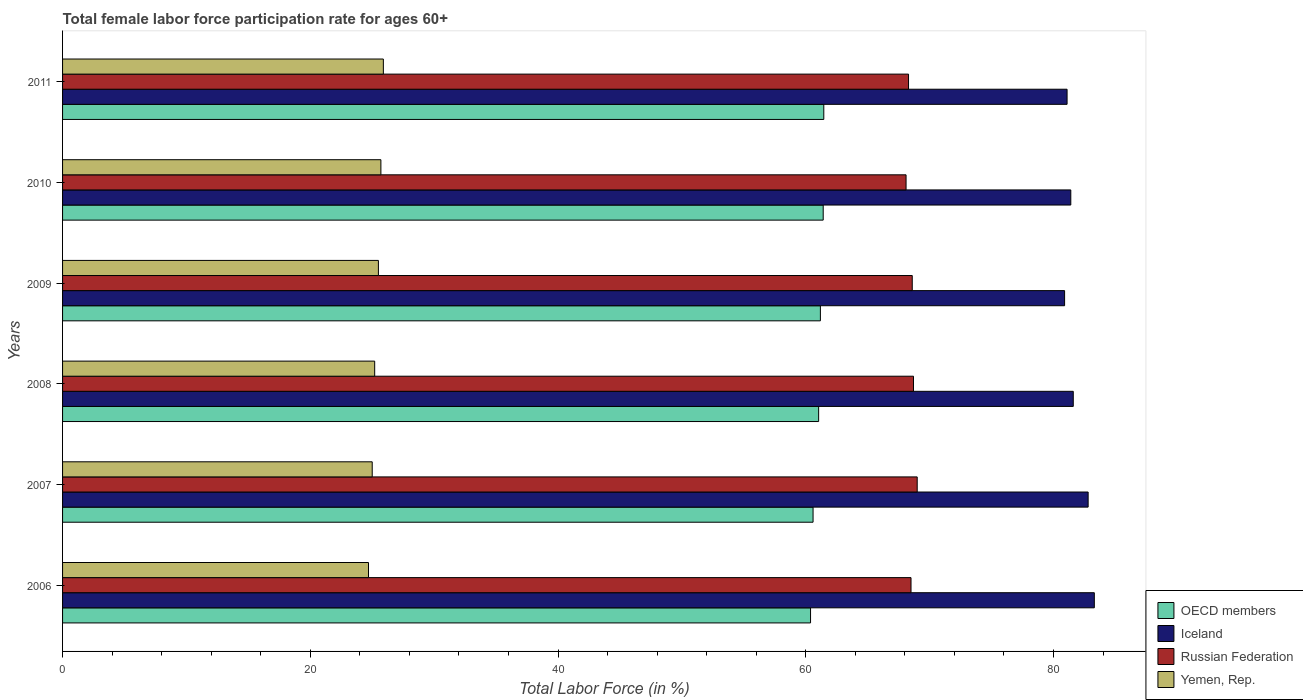Are the number of bars per tick equal to the number of legend labels?
Your answer should be compact. Yes. Are the number of bars on each tick of the Y-axis equal?
Offer a terse response. Yes. How many bars are there on the 6th tick from the bottom?
Make the answer very short. 4. What is the label of the 6th group of bars from the top?
Provide a short and direct response. 2006. What is the female labor force participation rate in Iceland in 2011?
Offer a terse response. 81.1. Across all years, what is the minimum female labor force participation rate in Iceland?
Offer a very short reply. 80.9. In which year was the female labor force participation rate in OECD members minimum?
Make the answer very short. 2006. What is the total female labor force participation rate in OECD members in the graph?
Provide a succinct answer. 366.08. What is the difference between the female labor force participation rate in Yemen, Rep. in 2007 and that in 2010?
Your answer should be compact. -0.7. What is the difference between the female labor force participation rate in Iceland in 2010 and the female labor force participation rate in OECD members in 2009?
Keep it short and to the point. 20.22. What is the average female labor force participation rate in Russian Federation per year?
Give a very brief answer. 68.53. In the year 2007, what is the difference between the female labor force participation rate in OECD members and female labor force participation rate in Russian Federation?
Your answer should be compact. -8.41. What is the ratio of the female labor force participation rate in Iceland in 2007 to that in 2011?
Make the answer very short. 1.02. Is the female labor force participation rate in OECD members in 2008 less than that in 2009?
Make the answer very short. Yes. Is the difference between the female labor force participation rate in OECD members in 2006 and 2007 greater than the difference between the female labor force participation rate in Russian Federation in 2006 and 2007?
Your answer should be compact. Yes. What is the difference between the highest and the second highest female labor force participation rate in Russian Federation?
Offer a terse response. 0.3. What is the difference between the highest and the lowest female labor force participation rate in Iceland?
Give a very brief answer. 2.4. In how many years, is the female labor force participation rate in Russian Federation greater than the average female labor force participation rate in Russian Federation taken over all years?
Offer a terse response. 3. Is it the case that in every year, the sum of the female labor force participation rate in OECD members and female labor force participation rate in Russian Federation is greater than the sum of female labor force participation rate in Iceland and female labor force participation rate in Yemen, Rep.?
Your answer should be compact. No. What does the 1st bar from the top in 2007 represents?
Provide a succinct answer. Yemen, Rep. Is it the case that in every year, the sum of the female labor force participation rate in OECD members and female labor force participation rate in Russian Federation is greater than the female labor force participation rate in Iceland?
Your response must be concise. Yes. How many bars are there?
Your response must be concise. 24. How many years are there in the graph?
Keep it short and to the point. 6. Are the values on the major ticks of X-axis written in scientific E-notation?
Provide a short and direct response. No. Does the graph contain any zero values?
Ensure brevity in your answer.  No. How many legend labels are there?
Offer a very short reply. 4. How are the legend labels stacked?
Your answer should be compact. Vertical. What is the title of the graph?
Provide a short and direct response. Total female labor force participation rate for ages 60+. What is the label or title of the X-axis?
Make the answer very short. Total Labor Force (in %). What is the label or title of the Y-axis?
Provide a short and direct response. Years. What is the Total Labor Force (in %) of OECD members in 2006?
Offer a terse response. 60.39. What is the Total Labor Force (in %) of Iceland in 2006?
Make the answer very short. 83.3. What is the Total Labor Force (in %) in Russian Federation in 2006?
Make the answer very short. 68.5. What is the Total Labor Force (in %) in Yemen, Rep. in 2006?
Offer a very short reply. 24.7. What is the Total Labor Force (in %) in OECD members in 2007?
Ensure brevity in your answer.  60.59. What is the Total Labor Force (in %) of Iceland in 2007?
Provide a succinct answer. 82.8. What is the Total Labor Force (in %) in Russian Federation in 2007?
Keep it short and to the point. 69. What is the Total Labor Force (in %) in Yemen, Rep. in 2007?
Make the answer very short. 25. What is the Total Labor Force (in %) in OECD members in 2008?
Keep it short and to the point. 61.04. What is the Total Labor Force (in %) of Iceland in 2008?
Your answer should be compact. 81.6. What is the Total Labor Force (in %) in Russian Federation in 2008?
Keep it short and to the point. 68.7. What is the Total Labor Force (in %) of Yemen, Rep. in 2008?
Ensure brevity in your answer.  25.2. What is the Total Labor Force (in %) of OECD members in 2009?
Offer a very short reply. 61.18. What is the Total Labor Force (in %) in Iceland in 2009?
Offer a terse response. 80.9. What is the Total Labor Force (in %) in Russian Federation in 2009?
Offer a very short reply. 68.6. What is the Total Labor Force (in %) in OECD members in 2010?
Provide a short and direct response. 61.41. What is the Total Labor Force (in %) of Iceland in 2010?
Your response must be concise. 81.4. What is the Total Labor Force (in %) of Russian Federation in 2010?
Your answer should be very brief. 68.1. What is the Total Labor Force (in %) in Yemen, Rep. in 2010?
Provide a short and direct response. 25.7. What is the Total Labor Force (in %) of OECD members in 2011?
Ensure brevity in your answer.  61.46. What is the Total Labor Force (in %) of Iceland in 2011?
Ensure brevity in your answer.  81.1. What is the Total Labor Force (in %) of Russian Federation in 2011?
Provide a short and direct response. 68.3. What is the Total Labor Force (in %) in Yemen, Rep. in 2011?
Keep it short and to the point. 25.9. Across all years, what is the maximum Total Labor Force (in %) of OECD members?
Make the answer very short. 61.46. Across all years, what is the maximum Total Labor Force (in %) of Iceland?
Offer a terse response. 83.3. Across all years, what is the maximum Total Labor Force (in %) in Yemen, Rep.?
Provide a succinct answer. 25.9. Across all years, what is the minimum Total Labor Force (in %) in OECD members?
Your answer should be compact. 60.39. Across all years, what is the minimum Total Labor Force (in %) of Iceland?
Provide a succinct answer. 80.9. Across all years, what is the minimum Total Labor Force (in %) in Russian Federation?
Keep it short and to the point. 68.1. Across all years, what is the minimum Total Labor Force (in %) of Yemen, Rep.?
Your response must be concise. 24.7. What is the total Total Labor Force (in %) in OECD members in the graph?
Make the answer very short. 366.08. What is the total Total Labor Force (in %) in Iceland in the graph?
Offer a terse response. 491.1. What is the total Total Labor Force (in %) of Russian Federation in the graph?
Make the answer very short. 411.2. What is the total Total Labor Force (in %) of Yemen, Rep. in the graph?
Make the answer very short. 152. What is the difference between the Total Labor Force (in %) in OECD members in 2006 and that in 2007?
Offer a very short reply. -0.2. What is the difference between the Total Labor Force (in %) of OECD members in 2006 and that in 2008?
Make the answer very short. -0.65. What is the difference between the Total Labor Force (in %) of Iceland in 2006 and that in 2008?
Provide a succinct answer. 1.7. What is the difference between the Total Labor Force (in %) of OECD members in 2006 and that in 2009?
Your answer should be compact. -0.8. What is the difference between the Total Labor Force (in %) of Yemen, Rep. in 2006 and that in 2009?
Your answer should be very brief. -0.8. What is the difference between the Total Labor Force (in %) in OECD members in 2006 and that in 2010?
Make the answer very short. -1.02. What is the difference between the Total Labor Force (in %) of Yemen, Rep. in 2006 and that in 2010?
Provide a short and direct response. -1. What is the difference between the Total Labor Force (in %) of OECD members in 2006 and that in 2011?
Ensure brevity in your answer.  -1.07. What is the difference between the Total Labor Force (in %) of Yemen, Rep. in 2006 and that in 2011?
Keep it short and to the point. -1.2. What is the difference between the Total Labor Force (in %) of OECD members in 2007 and that in 2008?
Keep it short and to the point. -0.45. What is the difference between the Total Labor Force (in %) in OECD members in 2007 and that in 2009?
Give a very brief answer. -0.59. What is the difference between the Total Labor Force (in %) in Iceland in 2007 and that in 2009?
Your response must be concise. 1.9. What is the difference between the Total Labor Force (in %) of Russian Federation in 2007 and that in 2009?
Keep it short and to the point. 0.4. What is the difference between the Total Labor Force (in %) in Yemen, Rep. in 2007 and that in 2009?
Offer a very short reply. -0.5. What is the difference between the Total Labor Force (in %) of OECD members in 2007 and that in 2010?
Keep it short and to the point. -0.82. What is the difference between the Total Labor Force (in %) of Iceland in 2007 and that in 2010?
Make the answer very short. 1.4. What is the difference between the Total Labor Force (in %) in OECD members in 2007 and that in 2011?
Your answer should be very brief. -0.87. What is the difference between the Total Labor Force (in %) in Iceland in 2007 and that in 2011?
Offer a very short reply. 1.7. What is the difference between the Total Labor Force (in %) in Russian Federation in 2007 and that in 2011?
Provide a succinct answer. 0.7. What is the difference between the Total Labor Force (in %) in Yemen, Rep. in 2007 and that in 2011?
Offer a terse response. -0.9. What is the difference between the Total Labor Force (in %) in OECD members in 2008 and that in 2009?
Provide a short and direct response. -0.14. What is the difference between the Total Labor Force (in %) of Iceland in 2008 and that in 2009?
Offer a very short reply. 0.7. What is the difference between the Total Labor Force (in %) in Russian Federation in 2008 and that in 2009?
Ensure brevity in your answer.  0.1. What is the difference between the Total Labor Force (in %) of OECD members in 2008 and that in 2010?
Provide a succinct answer. -0.37. What is the difference between the Total Labor Force (in %) in OECD members in 2008 and that in 2011?
Give a very brief answer. -0.42. What is the difference between the Total Labor Force (in %) of Russian Federation in 2008 and that in 2011?
Provide a succinct answer. 0.4. What is the difference between the Total Labor Force (in %) in OECD members in 2009 and that in 2010?
Your response must be concise. -0.23. What is the difference between the Total Labor Force (in %) in Russian Federation in 2009 and that in 2010?
Make the answer very short. 0.5. What is the difference between the Total Labor Force (in %) in OECD members in 2009 and that in 2011?
Keep it short and to the point. -0.27. What is the difference between the Total Labor Force (in %) in Iceland in 2009 and that in 2011?
Offer a terse response. -0.2. What is the difference between the Total Labor Force (in %) of Yemen, Rep. in 2009 and that in 2011?
Make the answer very short. -0.4. What is the difference between the Total Labor Force (in %) of OECD members in 2010 and that in 2011?
Your answer should be compact. -0.05. What is the difference between the Total Labor Force (in %) in Russian Federation in 2010 and that in 2011?
Provide a succinct answer. -0.2. What is the difference between the Total Labor Force (in %) of Yemen, Rep. in 2010 and that in 2011?
Ensure brevity in your answer.  -0.2. What is the difference between the Total Labor Force (in %) of OECD members in 2006 and the Total Labor Force (in %) of Iceland in 2007?
Keep it short and to the point. -22.41. What is the difference between the Total Labor Force (in %) of OECD members in 2006 and the Total Labor Force (in %) of Russian Federation in 2007?
Make the answer very short. -8.61. What is the difference between the Total Labor Force (in %) of OECD members in 2006 and the Total Labor Force (in %) of Yemen, Rep. in 2007?
Offer a very short reply. 35.39. What is the difference between the Total Labor Force (in %) of Iceland in 2006 and the Total Labor Force (in %) of Yemen, Rep. in 2007?
Give a very brief answer. 58.3. What is the difference between the Total Labor Force (in %) of Russian Federation in 2006 and the Total Labor Force (in %) of Yemen, Rep. in 2007?
Offer a very short reply. 43.5. What is the difference between the Total Labor Force (in %) in OECD members in 2006 and the Total Labor Force (in %) in Iceland in 2008?
Make the answer very short. -21.21. What is the difference between the Total Labor Force (in %) in OECD members in 2006 and the Total Labor Force (in %) in Russian Federation in 2008?
Give a very brief answer. -8.31. What is the difference between the Total Labor Force (in %) of OECD members in 2006 and the Total Labor Force (in %) of Yemen, Rep. in 2008?
Give a very brief answer. 35.19. What is the difference between the Total Labor Force (in %) in Iceland in 2006 and the Total Labor Force (in %) in Russian Federation in 2008?
Provide a succinct answer. 14.6. What is the difference between the Total Labor Force (in %) in Iceland in 2006 and the Total Labor Force (in %) in Yemen, Rep. in 2008?
Your answer should be very brief. 58.1. What is the difference between the Total Labor Force (in %) in Russian Federation in 2006 and the Total Labor Force (in %) in Yemen, Rep. in 2008?
Keep it short and to the point. 43.3. What is the difference between the Total Labor Force (in %) in OECD members in 2006 and the Total Labor Force (in %) in Iceland in 2009?
Your response must be concise. -20.51. What is the difference between the Total Labor Force (in %) in OECD members in 2006 and the Total Labor Force (in %) in Russian Federation in 2009?
Your response must be concise. -8.21. What is the difference between the Total Labor Force (in %) of OECD members in 2006 and the Total Labor Force (in %) of Yemen, Rep. in 2009?
Keep it short and to the point. 34.89. What is the difference between the Total Labor Force (in %) of Iceland in 2006 and the Total Labor Force (in %) of Yemen, Rep. in 2009?
Offer a terse response. 57.8. What is the difference between the Total Labor Force (in %) of OECD members in 2006 and the Total Labor Force (in %) of Iceland in 2010?
Keep it short and to the point. -21.01. What is the difference between the Total Labor Force (in %) of OECD members in 2006 and the Total Labor Force (in %) of Russian Federation in 2010?
Keep it short and to the point. -7.71. What is the difference between the Total Labor Force (in %) of OECD members in 2006 and the Total Labor Force (in %) of Yemen, Rep. in 2010?
Give a very brief answer. 34.69. What is the difference between the Total Labor Force (in %) of Iceland in 2006 and the Total Labor Force (in %) of Yemen, Rep. in 2010?
Give a very brief answer. 57.6. What is the difference between the Total Labor Force (in %) in Russian Federation in 2006 and the Total Labor Force (in %) in Yemen, Rep. in 2010?
Provide a succinct answer. 42.8. What is the difference between the Total Labor Force (in %) of OECD members in 2006 and the Total Labor Force (in %) of Iceland in 2011?
Offer a terse response. -20.71. What is the difference between the Total Labor Force (in %) in OECD members in 2006 and the Total Labor Force (in %) in Russian Federation in 2011?
Give a very brief answer. -7.91. What is the difference between the Total Labor Force (in %) of OECD members in 2006 and the Total Labor Force (in %) of Yemen, Rep. in 2011?
Ensure brevity in your answer.  34.49. What is the difference between the Total Labor Force (in %) of Iceland in 2006 and the Total Labor Force (in %) of Russian Federation in 2011?
Keep it short and to the point. 15. What is the difference between the Total Labor Force (in %) in Iceland in 2006 and the Total Labor Force (in %) in Yemen, Rep. in 2011?
Ensure brevity in your answer.  57.4. What is the difference between the Total Labor Force (in %) of Russian Federation in 2006 and the Total Labor Force (in %) of Yemen, Rep. in 2011?
Your answer should be very brief. 42.6. What is the difference between the Total Labor Force (in %) of OECD members in 2007 and the Total Labor Force (in %) of Iceland in 2008?
Keep it short and to the point. -21.01. What is the difference between the Total Labor Force (in %) in OECD members in 2007 and the Total Labor Force (in %) in Russian Federation in 2008?
Offer a very short reply. -8.11. What is the difference between the Total Labor Force (in %) of OECD members in 2007 and the Total Labor Force (in %) of Yemen, Rep. in 2008?
Give a very brief answer. 35.39. What is the difference between the Total Labor Force (in %) of Iceland in 2007 and the Total Labor Force (in %) of Russian Federation in 2008?
Give a very brief answer. 14.1. What is the difference between the Total Labor Force (in %) in Iceland in 2007 and the Total Labor Force (in %) in Yemen, Rep. in 2008?
Your answer should be very brief. 57.6. What is the difference between the Total Labor Force (in %) of Russian Federation in 2007 and the Total Labor Force (in %) of Yemen, Rep. in 2008?
Give a very brief answer. 43.8. What is the difference between the Total Labor Force (in %) of OECD members in 2007 and the Total Labor Force (in %) of Iceland in 2009?
Provide a short and direct response. -20.31. What is the difference between the Total Labor Force (in %) in OECD members in 2007 and the Total Labor Force (in %) in Russian Federation in 2009?
Ensure brevity in your answer.  -8.01. What is the difference between the Total Labor Force (in %) of OECD members in 2007 and the Total Labor Force (in %) of Yemen, Rep. in 2009?
Ensure brevity in your answer.  35.09. What is the difference between the Total Labor Force (in %) in Iceland in 2007 and the Total Labor Force (in %) in Russian Federation in 2009?
Make the answer very short. 14.2. What is the difference between the Total Labor Force (in %) of Iceland in 2007 and the Total Labor Force (in %) of Yemen, Rep. in 2009?
Provide a short and direct response. 57.3. What is the difference between the Total Labor Force (in %) of Russian Federation in 2007 and the Total Labor Force (in %) of Yemen, Rep. in 2009?
Give a very brief answer. 43.5. What is the difference between the Total Labor Force (in %) in OECD members in 2007 and the Total Labor Force (in %) in Iceland in 2010?
Offer a terse response. -20.81. What is the difference between the Total Labor Force (in %) of OECD members in 2007 and the Total Labor Force (in %) of Russian Federation in 2010?
Provide a short and direct response. -7.51. What is the difference between the Total Labor Force (in %) in OECD members in 2007 and the Total Labor Force (in %) in Yemen, Rep. in 2010?
Ensure brevity in your answer.  34.89. What is the difference between the Total Labor Force (in %) of Iceland in 2007 and the Total Labor Force (in %) of Russian Federation in 2010?
Keep it short and to the point. 14.7. What is the difference between the Total Labor Force (in %) of Iceland in 2007 and the Total Labor Force (in %) of Yemen, Rep. in 2010?
Your answer should be very brief. 57.1. What is the difference between the Total Labor Force (in %) in Russian Federation in 2007 and the Total Labor Force (in %) in Yemen, Rep. in 2010?
Provide a succinct answer. 43.3. What is the difference between the Total Labor Force (in %) in OECD members in 2007 and the Total Labor Force (in %) in Iceland in 2011?
Your answer should be very brief. -20.51. What is the difference between the Total Labor Force (in %) of OECD members in 2007 and the Total Labor Force (in %) of Russian Federation in 2011?
Provide a succinct answer. -7.71. What is the difference between the Total Labor Force (in %) in OECD members in 2007 and the Total Labor Force (in %) in Yemen, Rep. in 2011?
Provide a succinct answer. 34.69. What is the difference between the Total Labor Force (in %) of Iceland in 2007 and the Total Labor Force (in %) of Yemen, Rep. in 2011?
Your response must be concise. 56.9. What is the difference between the Total Labor Force (in %) of Russian Federation in 2007 and the Total Labor Force (in %) of Yemen, Rep. in 2011?
Your answer should be very brief. 43.1. What is the difference between the Total Labor Force (in %) in OECD members in 2008 and the Total Labor Force (in %) in Iceland in 2009?
Your response must be concise. -19.86. What is the difference between the Total Labor Force (in %) in OECD members in 2008 and the Total Labor Force (in %) in Russian Federation in 2009?
Make the answer very short. -7.56. What is the difference between the Total Labor Force (in %) of OECD members in 2008 and the Total Labor Force (in %) of Yemen, Rep. in 2009?
Give a very brief answer. 35.54. What is the difference between the Total Labor Force (in %) of Iceland in 2008 and the Total Labor Force (in %) of Yemen, Rep. in 2009?
Offer a very short reply. 56.1. What is the difference between the Total Labor Force (in %) in Russian Federation in 2008 and the Total Labor Force (in %) in Yemen, Rep. in 2009?
Make the answer very short. 43.2. What is the difference between the Total Labor Force (in %) in OECD members in 2008 and the Total Labor Force (in %) in Iceland in 2010?
Offer a very short reply. -20.36. What is the difference between the Total Labor Force (in %) in OECD members in 2008 and the Total Labor Force (in %) in Russian Federation in 2010?
Offer a terse response. -7.06. What is the difference between the Total Labor Force (in %) of OECD members in 2008 and the Total Labor Force (in %) of Yemen, Rep. in 2010?
Offer a terse response. 35.34. What is the difference between the Total Labor Force (in %) of Iceland in 2008 and the Total Labor Force (in %) of Russian Federation in 2010?
Give a very brief answer. 13.5. What is the difference between the Total Labor Force (in %) of Iceland in 2008 and the Total Labor Force (in %) of Yemen, Rep. in 2010?
Ensure brevity in your answer.  55.9. What is the difference between the Total Labor Force (in %) of Russian Federation in 2008 and the Total Labor Force (in %) of Yemen, Rep. in 2010?
Offer a terse response. 43. What is the difference between the Total Labor Force (in %) of OECD members in 2008 and the Total Labor Force (in %) of Iceland in 2011?
Provide a short and direct response. -20.06. What is the difference between the Total Labor Force (in %) of OECD members in 2008 and the Total Labor Force (in %) of Russian Federation in 2011?
Ensure brevity in your answer.  -7.26. What is the difference between the Total Labor Force (in %) in OECD members in 2008 and the Total Labor Force (in %) in Yemen, Rep. in 2011?
Your response must be concise. 35.14. What is the difference between the Total Labor Force (in %) in Iceland in 2008 and the Total Labor Force (in %) in Yemen, Rep. in 2011?
Your answer should be very brief. 55.7. What is the difference between the Total Labor Force (in %) of Russian Federation in 2008 and the Total Labor Force (in %) of Yemen, Rep. in 2011?
Give a very brief answer. 42.8. What is the difference between the Total Labor Force (in %) in OECD members in 2009 and the Total Labor Force (in %) in Iceland in 2010?
Your answer should be very brief. -20.22. What is the difference between the Total Labor Force (in %) in OECD members in 2009 and the Total Labor Force (in %) in Russian Federation in 2010?
Ensure brevity in your answer.  -6.92. What is the difference between the Total Labor Force (in %) of OECD members in 2009 and the Total Labor Force (in %) of Yemen, Rep. in 2010?
Make the answer very short. 35.48. What is the difference between the Total Labor Force (in %) of Iceland in 2009 and the Total Labor Force (in %) of Yemen, Rep. in 2010?
Your response must be concise. 55.2. What is the difference between the Total Labor Force (in %) in Russian Federation in 2009 and the Total Labor Force (in %) in Yemen, Rep. in 2010?
Ensure brevity in your answer.  42.9. What is the difference between the Total Labor Force (in %) in OECD members in 2009 and the Total Labor Force (in %) in Iceland in 2011?
Offer a terse response. -19.92. What is the difference between the Total Labor Force (in %) of OECD members in 2009 and the Total Labor Force (in %) of Russian Federation in 2011?
Offer a very short reply. -7.12. What is the difference between the Total Labor Force (in %) of OECD members in 2009 and the Total Labor Force (in %) of Yemen, Rep. in 2011?
Give a very brief answer. 35.28. What is the difference between the Total Labor Force (in %) of Iceland in 2009 and the Total Labor Force (in %) of Russian Federation in 2011?
Offer a very short reply. 12.6. What is the difference between the Total Labor Force (in %) in Iceland in 2009 and the Total Labor Force (in %) in Yemen, Rep. in 2011?
Make the answer very short. 55. What is the difference between the Total Labor Force (in %) in Russian Federation in 2009 and the Total Labor Force (in %) in Yemen, Rep. in 2011?
Your response must be concise. 42.7. What is the difference between the Total Labor Force (in %) in OECD members in 2010 and the Total Labor Force (in %) in Iceland in 2011?
Provide a short and direct response. -19.69. What is the difference between the Total Labor Force (in %) of OECD members in 2010 and the Total Labor Force (in %) of Russian Federation in 2011?
Keep it short and to the point. -6.89. What is the difference between the Total Labor Force (in %) of OECD members in 2010 and the Total Labor Force (in %) of Yemen, Rep. in 2011?
Ensure brevity in your answer.  35.51. What is the difference between the Total Labor Force (in %) in Iceland in 2010 and the Total Labor Force (in %) in Yemen, Rep. in 2011?
Your answer should be very brief. 55.5. What is the difference between the Total Labor Force (in %) of Russian Federation in 2010 and the Total Labor Force (in %) of Yemen, Rep. in 2011?
Your response must be concise. 42.2. What is the average Total Labor Force (in %) in OECD members per year?
Offer a very short reply. 61.01. What is the average Total Labor Force (in %) of Iceland per year?
Offer a very short reply. 81.85. What is the average Total Labor Force (in %) in Russian Federation per year?
Give a very brief answer. 68.53. What is the average Total Labor Force (in %) in Yemen, Rep. per year?
Ensure brevity in your answer.  25.33. In the year 2006, what is the difference between the Total Labor Force (in %) of OECD members and Total Labor Force (in %) of Iceland?
Your response must be concise. -22.91. In the year 2006, what is the difference between the Total Labor Force (in %) in OECD members and Total Labor Force (in %) in Russian Federation?
Ensure brevity in your answer.  -8.11. In the year 2006, what is the difference between the Total Labor Force (in %) in OECD members and Total Labor Force (in %) in Yemen, Rep.?
Offer a very short reply. 35.69. In the year 2006, what is the difference between the Total Labor Force (in %) in Iceland and Total Labor Force (in %) in Russian Federation?
Offer a terse response. 14.8. In the year 2006, what is the difference between the Total Labor Force (in %) in Iceland and Total Labor Force (in %) in Yemen, Rep.?
Your answer should be very brief. 58.6. In the year 2006, what is the difference between the Total Labor Force (in %) of Russian Federation and Total Labor Force (in %) of Yemen, Rep.?
Your answer should be compact. 43.8. In the year 2007, what is the difference between the Total Labor Force (in %) of OECD members and Total Labor Force (in %) of Iceland?
Your response must be concise. -22.21. In the year 2007, what is the difference between the Total Labor Force (in %) of OECD members and Total Labor Force (in %) of Russian Federation?
Keep it short and to the point. -8.41. In the year 2007, what is the difference between the Total Labor Force (in %) of OECD members and Total Labor Force (in %) of Yemen, Rep.?
Ensure brevity in your answer.  35.59. In the year 2007, what is the difference between the Total Labor Force (in %) in Iceland and Total Labor Force (in %) in Yemen, Rep.?
Give a very brief answer. 57.8. In the year 2008, what is the difference between the Total Labor Force (in %) of OECD members and Total Labor Force (in %) of Iceland?
Give a very brief answer. -20.56. In the year 2008, what is the difference between the Total Labor Force (in %) of OECD members and Total Labor Force (in %) of Russian Federation?
Offer a terse response. -7.66. In the year 2008, what is the difference between the Total Labor Force (in %) in OECD members and Total Labor Force (in %) in Yemen, Rep.?
Offer a terse response. 35.84. In the year 2008, what is the difference between the Total Labor Force (in %) of Iceland and Total Labor Force (in %) of Yemen, Rep.?
Your answer should be very brief. 56.4. In the year 2008, what is the difference between the Total Labor Force (in %) of Russian Federation and Total Labor Force (in %) of Yemen, Rep.?
Offer a very short reply. 43.5. In the year 2009, what is the difference between the Total Labor Force (in %) in OECD members and Total Labor Force (in %) in Iceland?
Keep it short and to the point. -19.72. In the year 2009, what is the difference between the Total Labor Force (in %) of OECD members and Total Labor Force (in %) of Russian Federation?
Offer a very short reply. -7.42. In the year 2009, what is the difference between the Total Labor Force (in %) of OECD members and Total Labor Force (in %) of Yemen, Rep.?
Give a very brief answer. 35.68. In the year 2009, what is the difference between the Total Labor Force (in %) of Iceland and Total Labor Force (in %) of Russian Federation?
Offer a terse response. 12.3. In the year 2009, what is the difference between the Total Labor Force (in %) in Iceland and Total Labor Force (in %) in Yemen, Rep.?
Provide a short and direct response. 55.4. In the year 2009, what is the difference between the Total Labor Force (in %) of Russian Federation and Total Labor Force (in %) of Yemen, Rep.?
Keep it short and to the point. 43.1. In the year 2010, what is the difference between the Total Labor Force (in %) of OECD members and Total Labor Force (in %) of Iceland?
Provide a short and direct response. -19.99. In the year 2010, what is the difference between the Total Labor Force (in %) of OECD members and Total Labor Force (in %) of Russian Federation?
Provide a succinct answer. -6.69. In the year 2010, what is the difference between the Total Labor Force (in %) of OECD members and Total Labor Force (in %) of Yemen, Rep.?
Ensure brevity in your answer.  35.71. In the year 2010, what is the difference between the Total Labor Force (in %) of Iceland and Total Labor Force (in %) of Yemen, Rep.?
Offer a terse response. 55.7. In the year 2010, what is the difference between the Total Labor Force (in %) of Russian Federation and Total Labor Force (in %) of Yemen, Rep.?
Provide a succinct answer. 42.4. In the year 2011, what is the difference between the Total Labor Force (in %) of OECD members and Total Labor Force (in %) of Iceland?
Your response must be concise. -19.64. In the year 2011, what is the difference between the Total Labor Force (in %) in OECD members and Total Labor Force (in %) in Russian Federation?
Provide a succinct answer. -6.84. In the year 2011, what is the difference between the Total Labor Force (in %) in OECD members and Total Labor Force (in %) in Yemen, Rep.?
Give a very brief answer. 35.56. In the year 2011, what is the difference between the Total Labor Force (in %) in Iceland and Total Labor Force (in %) in Yemen, Rep.?
Ensure brevity in your answer.  55.2. In the year 2011, what is the difference between the Total Labor Force (in %) in Russian Federation and Total Labor Force (in %) in Yemen, Rep.?
Provide a short and direct response. 42.4. What is the ratio of the Total Labor Force (in %) in OECD members in 2006 to that in 2008?
Offer a terse response. 0.99. What is the ratio of the Total Labor Force (in %) in Iceland in 2006 to that in 2008?
Keep it short and to the point. 1.02. What is the ratio of the Total Labor Force (in %) in Yemen, Rep. in 2006 to that in 2008?
Ensure brevity in your answer.  0.98. What is the ratio of the Total Labor Force (in %) in Iceland in 2006 to that in 2009?
Ensure brevity in your answer.  1.03. What is the ratio of the Total Labor Force (in %) in Yemen, Rep. in 2006 to that in 2009?
Ensure brevity in your answer.  0.97. What is the ratio of the Total Labor Force (in %) of OECD members in 2006 to that in 2010?
Ensure brevity in your answer.  0.98. What is the ratio of the Total Labor Force (in %) in Iceland in 2006 to that in 2010?
Keep it short and to the point. 1.02. What is the ratio of the Total Labor Force (in %) in Russian Federation in 2006 to that in 2010?
Give a very brief answer. 1.01. What is the ratio of the Total Labor Force (in %) of Yemen, Rep. in 2006 to that in 2010?
Offer a very short reply. 0.96. What is the ratio of the Total Labor Force (in %) in OECD members in 2006 to that in 2011?
Provide a succinct answer. 0.98. What is the ratio of the Total Labor Force (in %) in Iceland in 2006 to that in 2011?
Ensure brevity in your answer.  1.03. What is the ratio of the Total Labor Force (in %) in Russian Federation in 2006 to that in 2011?
Offer a terse response. 1. What is the ratio of the Total Labor Force (in %) in Yemen, Rep. in 2006 to that in 2011?
Keep it short and to the point. 0.95. What is the ratio of the Total Labor Force (in %) in OECD members in 2007 to that in 2008?
Your answer should be very brief. 0.99. What is the ratio of the Total Labor Force (in %) in Iceland in 2007 to that in 2008?
Ensure brevity in your answer.  1.01. What is the ratio of the Total Labor Force (in %) in OECD members in 2007 to that in 2009?
Your response must be concise. 0.99. What is the ratio of the Total Labor Force (in %) in Iceland in 2007 to that in 2009?
Offer a very short reply. 1.02. What is the ratio of the Total Labor Force (in %) in Russian Federation in 2007 to that in 2009?
Your answer should be very brief. 1.01. What is the ratio of the Total Labor Force (in %) of Yemen, Rep. in 2007 to that in 2009?
Give a very brief answer. 0.98. What is the ratio of the Total Labor Force (in %) of OECD members in 2007 to that in 2010?
Offer a terse response. 0.99. What is the ratio of the Total Labor Force (in %) in Iceland in 2007 to that in 2010?
Keep it short and to the point. 1.02. What is the ratio of the Total Labor Force (in %) of Russian Federation in 2007 to that in 2010?
Your answer should be very brief. 1.01. What is the ratio of the Total Labor Force (in %) of Yemen, Rep. in 2007 to that in 2010?
Keep it short and to the point. 0.97. What is the ratio of the Total Labor Force (in %) in OECD members in 2007 to that in 2011?
Make the answer very short. 0.99. What is the ratio of the Total Labor Force (in %) of Iceland in 2007 to that in 2011?
Your answer should be compact. 1.02. What is the ratio of the Total Labor Force (in %) in Russian Federation in 2007 to that in 2011?
Your response must be concise. 1.01. What is the ratio of the Total Labor Force (in %) of Yemen, Rep. in 2007 to that in 2011?
Offer a very short reply. 0.97. What is the ratio of the Total Labor Force (in %) of OECD members in 2008 to that in 2009?
Offer a terse response. 1. What is the ratio of the Total Labor Force (in %) of Iceland in 2008 to that in 2009?
Offer a very short reply. 1.01. What is the ratio of the Total Labor Force (in %) of OECD members in 2008 to that in 2010?
Your answer should be very brief. 0.99. What is the ratio of the Total Labor Force (in %) in Russian Federation in 2008 to that in 2010?
Give a very brief answer. 1.01. What is the ratio of the Total Labor Force (in %) in Yemen, Rep. in 2008 to that in 2010?
Ensure brevity in your answer.  0.98. What is the ratio of the Total Labor Force (in %) in OECD members in 2008 to that in 2011?
Make the answer very short. 0.99. What is the ratio of the Total Labor Force (in %) of Iceland in 2008 to that in 2011?
Your answer should be compact. 1.01. What is the ratio of the Total Labor Force (in %) in Russian Federation in 2008 to that in 2011?
Your answer should be compact. 1.01. What is the ratio of the Total Labor Force (in %) of Iceland in 2009 to that in 2010?
Your answer should be compact. 0.99. What is the ratio of the Total Labor Force (in %) in Russian Federation in 2009 to that in 2010?
Keep it short and to the point. 1.01. What is the ratio of the Total Labor Force (in %) of Yemen, Rep. in 2009 to that in 2010?
Provide a short and direct response. 0.99. What is the ratio of the Total Labor Force (in %) in OECD members in 2009 to that in 2011?
Your response must be concise. 1. What is the ratio of the Total Labor Force (in %) of Iceland in 2009 to that in 2011?
Keep it short and to the point. 1. What is the ratio of the Total Labor Force (in %) of Yemen, Rep. in 2009 to that in 2011?
Keep it short and to the point. 0.98. What is the difference between the highest and the second highest Total Labor Force (in %) in OECD members?
Provide a succinct answer. 0.05. What is the difference between the highest and the second highest Total Labor Force (in %) in Iceland?
Provide a short and direct response. 0.5. What is the difference between the highest and the second highest Total Labor Force (in %) of Russian Federation?
Give a very brief answer. 0.3. What is the difference between the highest and the second highest Total Labor Force (in %) in Yemen, Rep.?
Your response must be concise. 0.2. What is the difference between the highest and the lowest Total Labor Force (in %) of OECD members?
Offer a very short reply. 1.07. What is the difference between the highest and the lowest Total Labor Force (in %) in Iceland?
Provide a succinct answer. 2.4. What is the difference between the highest and the lowest Total Labor Force (in %) in Russian Federation?
Make the answer very short. 0.9. What is the difference between the highest and the lowest Total Labor Force (in %) of Yemen, Rep.?
Your answer should be very brief. 1.2. 